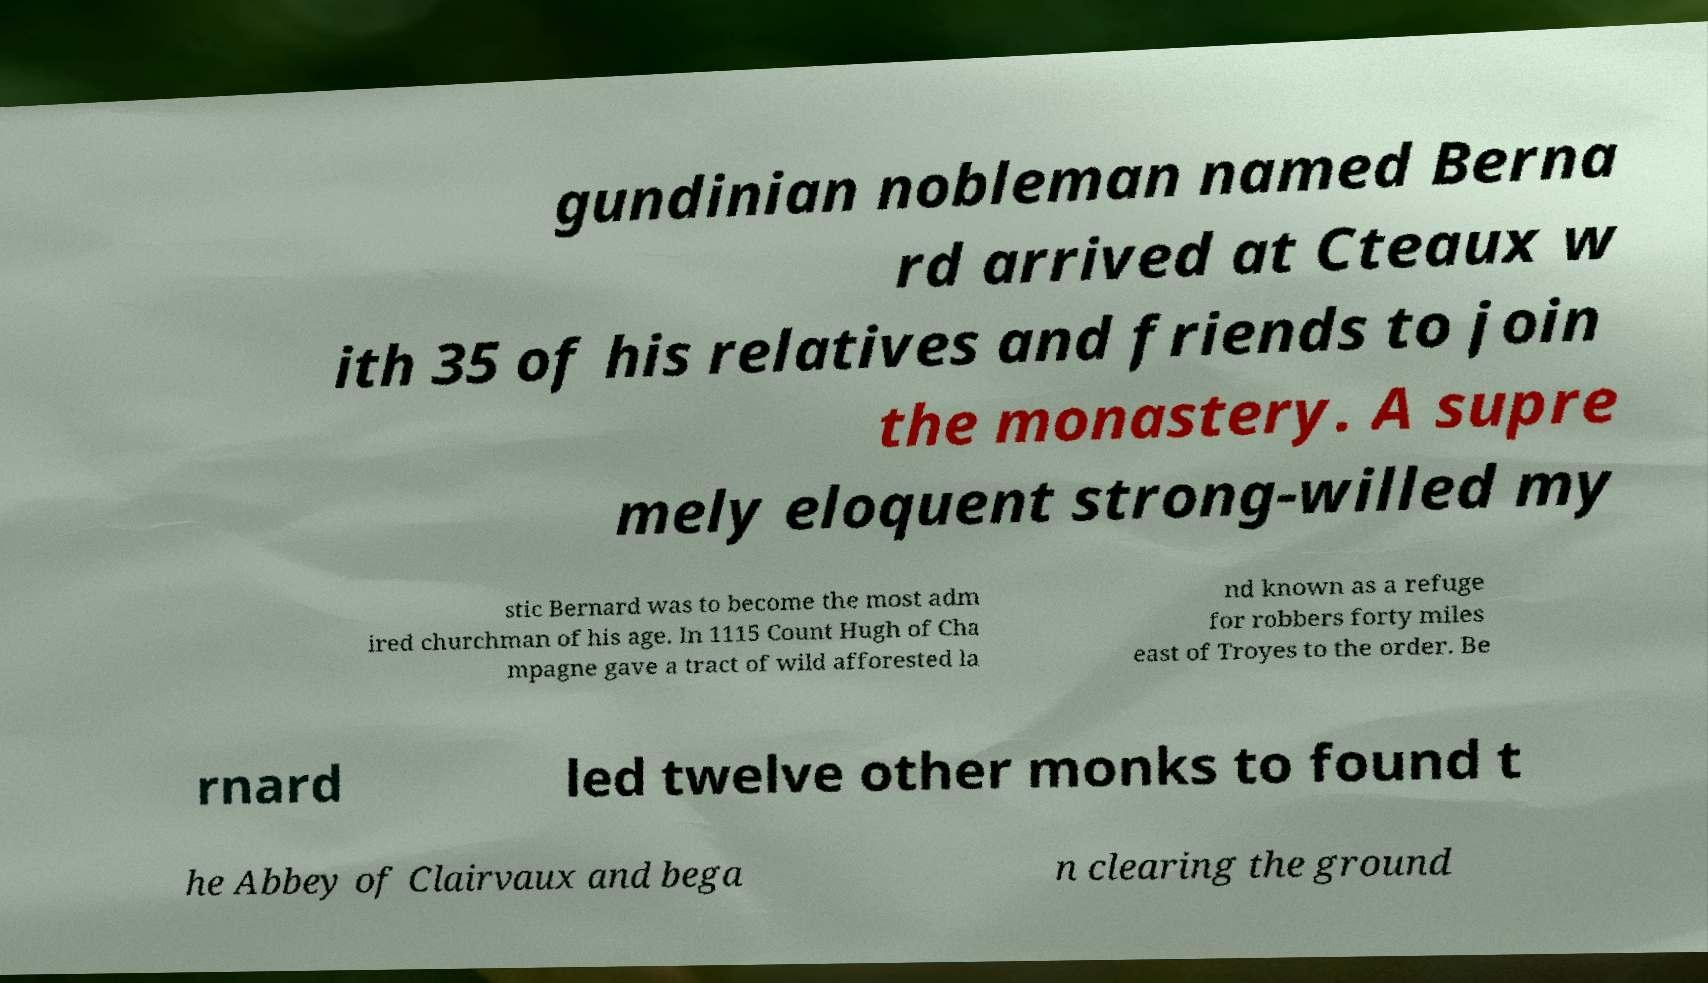For documentation purposes, I need the text within this image transcribed. Could you provide that? gundinian nobleman named Berna rd arrived at Cteaux w ith 35 of his relatives and friends to join the monastery. A supre mely eloquent strong-willed my stic Bernard was to become the most adm ired churchman of his age. In 1115 Count Hugh of Cha mpagne gave a tract of wild afforested la nd known as a refuge for robbers forty miles east of Troyes to the order. Be rnard led twelve other monks to found t he Abbey of Clairvaux and bega n clearing the ground 